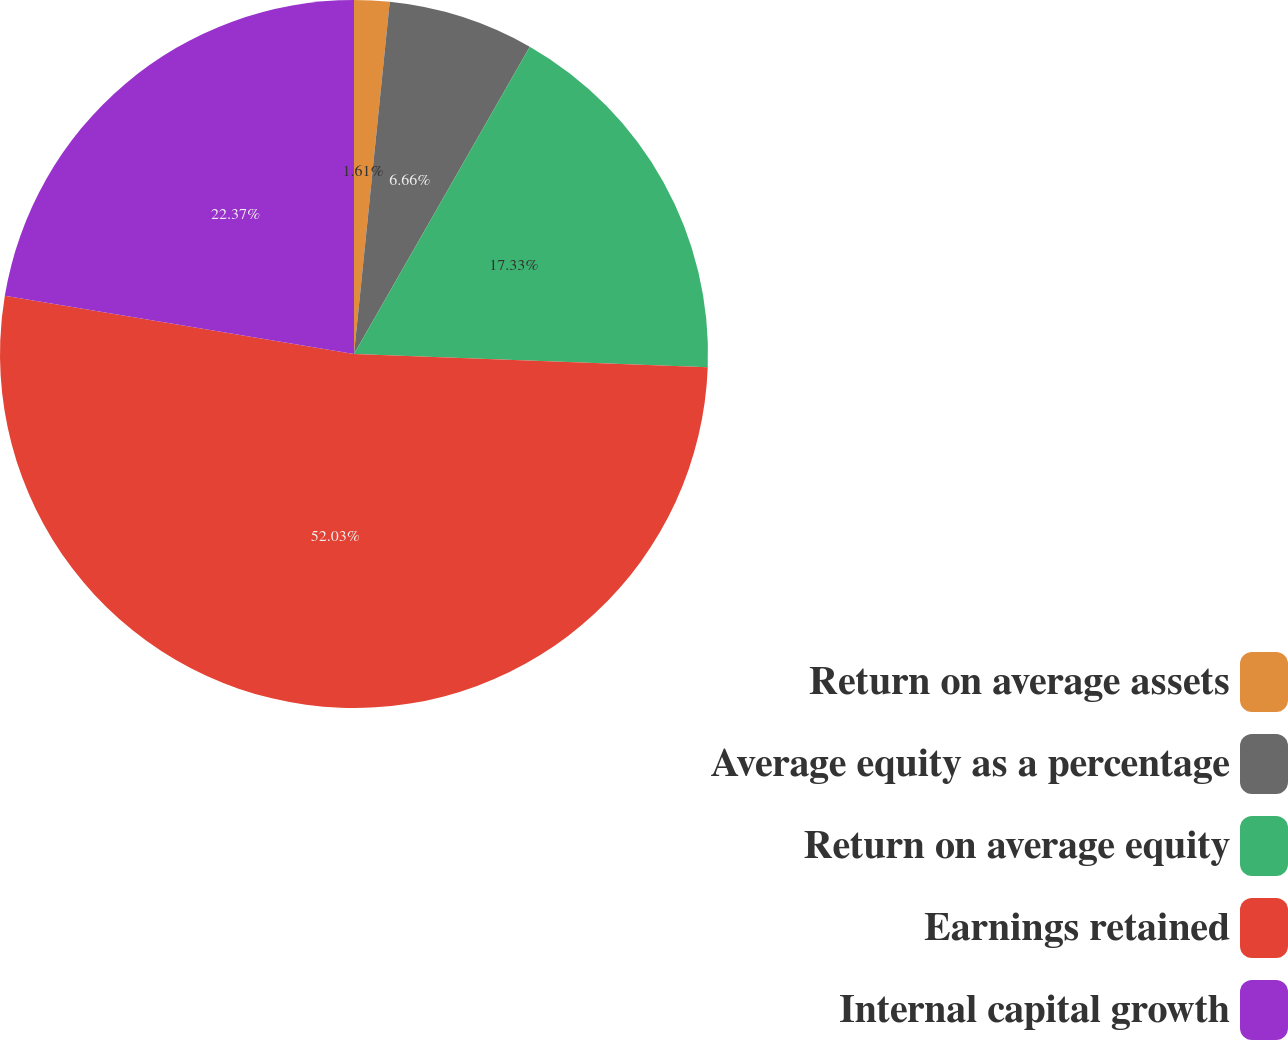<chart> <loc_0><loc_0><loc_500><loc_500><pie_chart><fcel>Return on average assets<fcel>Average equity as a percentage<fcel>Return on average equity<fcel>Earnings retained<fcel>Internal capital growth<nl><fcel>1.61%<fcel>6.66%<fcel>17.33%<fcel>52.03%<fcel>22.37%<nl></chart> 